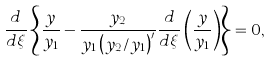Convert formula to latex. <formula><loc_0><loc_0><loc_500><loc_500>\frac { d } { d \xi } \left \{ { \frac { y } { y _ { 1 } } - \frac { y _ { 2 } } { y _ { 1 } \left ( { y _ { 2 } / y _ { 1 } } \right ) ^ { \prime } } \frac { d } { d \xi } \left ( { \frac { y } { y _ { 1 } } } \right ) } \right \} = 0 ,</formula> 